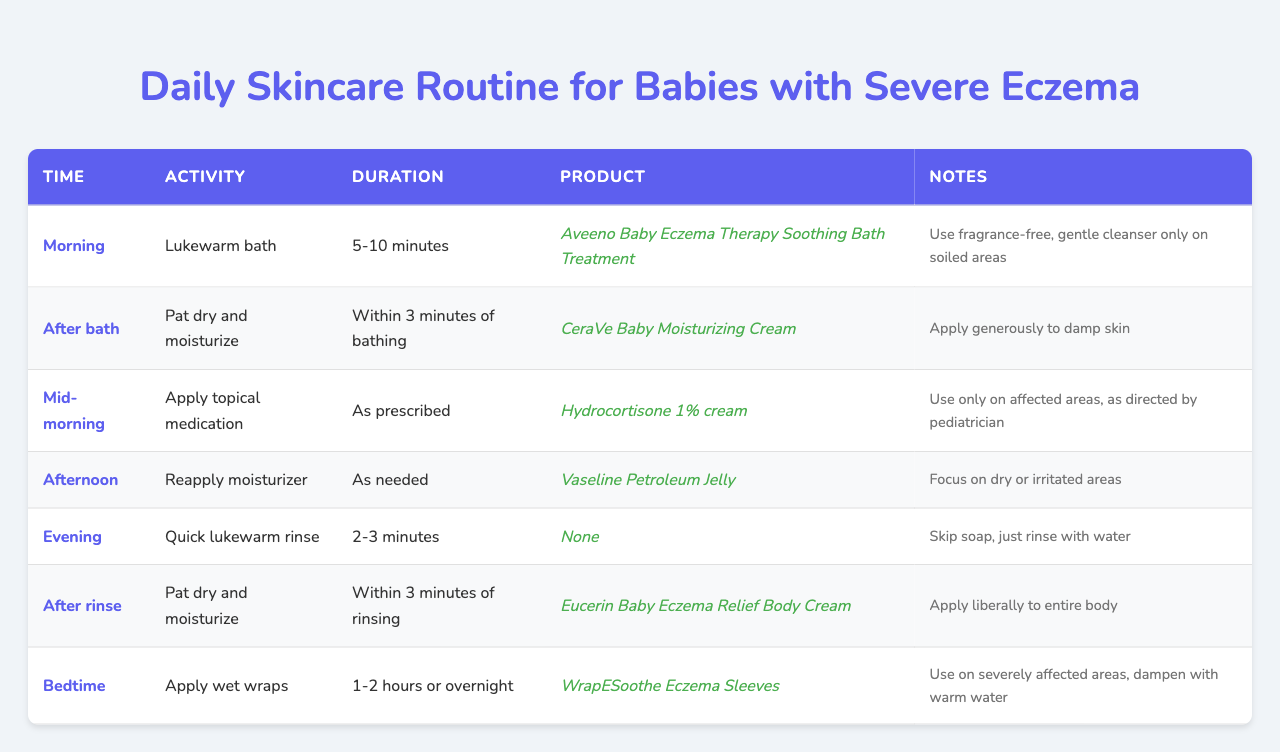What is the product used during the morning routine? According to the table, the product for the morning routine, which involves a lukewarm bath, is "Aveeno Baby Eczema Therapy Soothing Bath Treatment."
Answer: Aveeno Baby Eczema Therapy Soothing Bath Treatment How long should the lukewarm bath last? The table specifies that the duration of the morning lukewarm bath should be between 5 to 10 minutes.
Answer: 5-10 minutes Which activity is recommended immediately after the bath? According to the table, the activity recommended immediately after the bath is to "Pat dry and moisturize."
Answer: Pat dry and moisturize What product should be applied mid-morning? The table states that "Hydrocortisone 1% cream" should be applied mid-morning.
Answer: Hydrocortisone 1% cream Does the evening rinse require soap? The table mentions that during the evening's quick lukewarm rinse, you should "Skip soap" and just rinse with water.
Answer: Yes How much time do you have to moisturize after the afternoon reapplication? The table indicates that the moisturizer should be reapplied in the afternoon "As needed," which does not specify a timeframe.
Answer: As needed How many different types of products are used throughout the daily routine? By counting each unique product mentioned in the table, there are five different products: Aveeno Baby Eczema Therapy Soothing Bath Treatment, CeraVe Baby Moisturizing Cream, Hydrocortisone 1% cream, Vaseline Petroleum Jelly, and Eucerin Baby Eczema Relief Body Cream. The wet wraps use a different item, which brings the count to six if included.
Answer: 6 What is the intended use of WrapESoothe Eczema Sleeves? The table states that WrapESoothe Eczema Sleeves should be used on "severely affected areas" and to "dampen with warm water."
Answer: Severe areas How many activities involve a moisturizing step? By examining the table, the activities indicating a moisturizing step are: "Pat dry and moisturize" after the bath, "Reapply moisturizer" in the afternoon, and "Pat dry and moisturize" after the evening rinse, plus the "Apply wet wraps" activity. That totals four instances of applying moisturizer (two are the same).
Answer: 4 Is there any activity scheduled right before bedtime? The table shows that the activity scheduled right before bedtime is to "Apply wet wraps," which could be considered a part of the bedtime routine.
Answer: Yes 